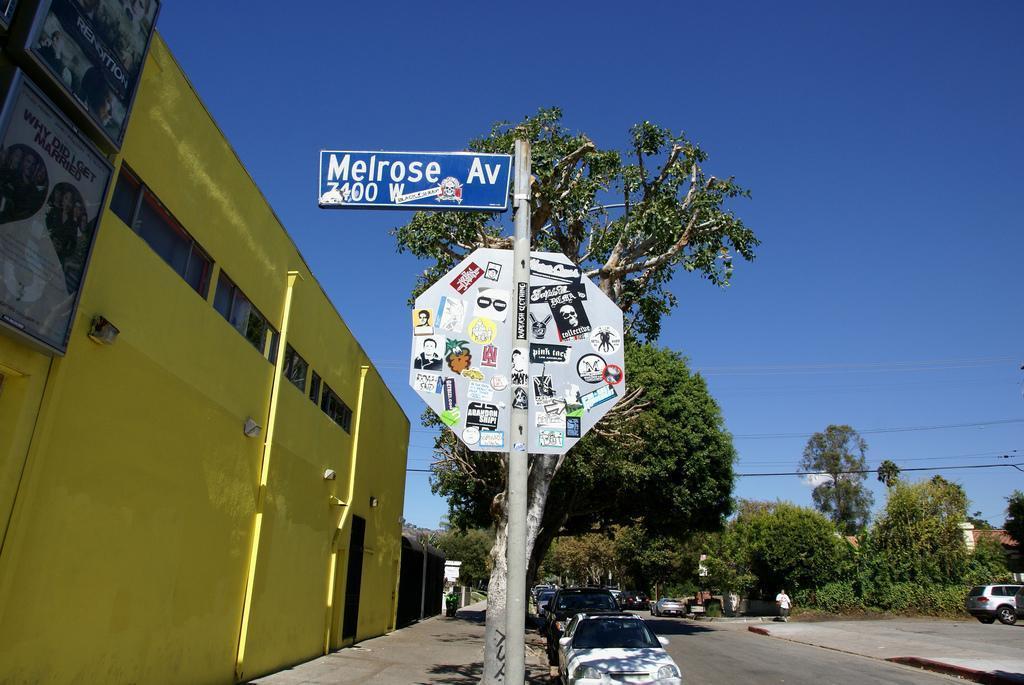How many clouds are in the sky?
Give a very brief answer. 0. How many dinosaurs are in the picture?
Give a very brief answer. 0. How many windows are on the building?
Give a very brief answer. 5. How many stop signs are there?
Give a very brief answer. 1. 